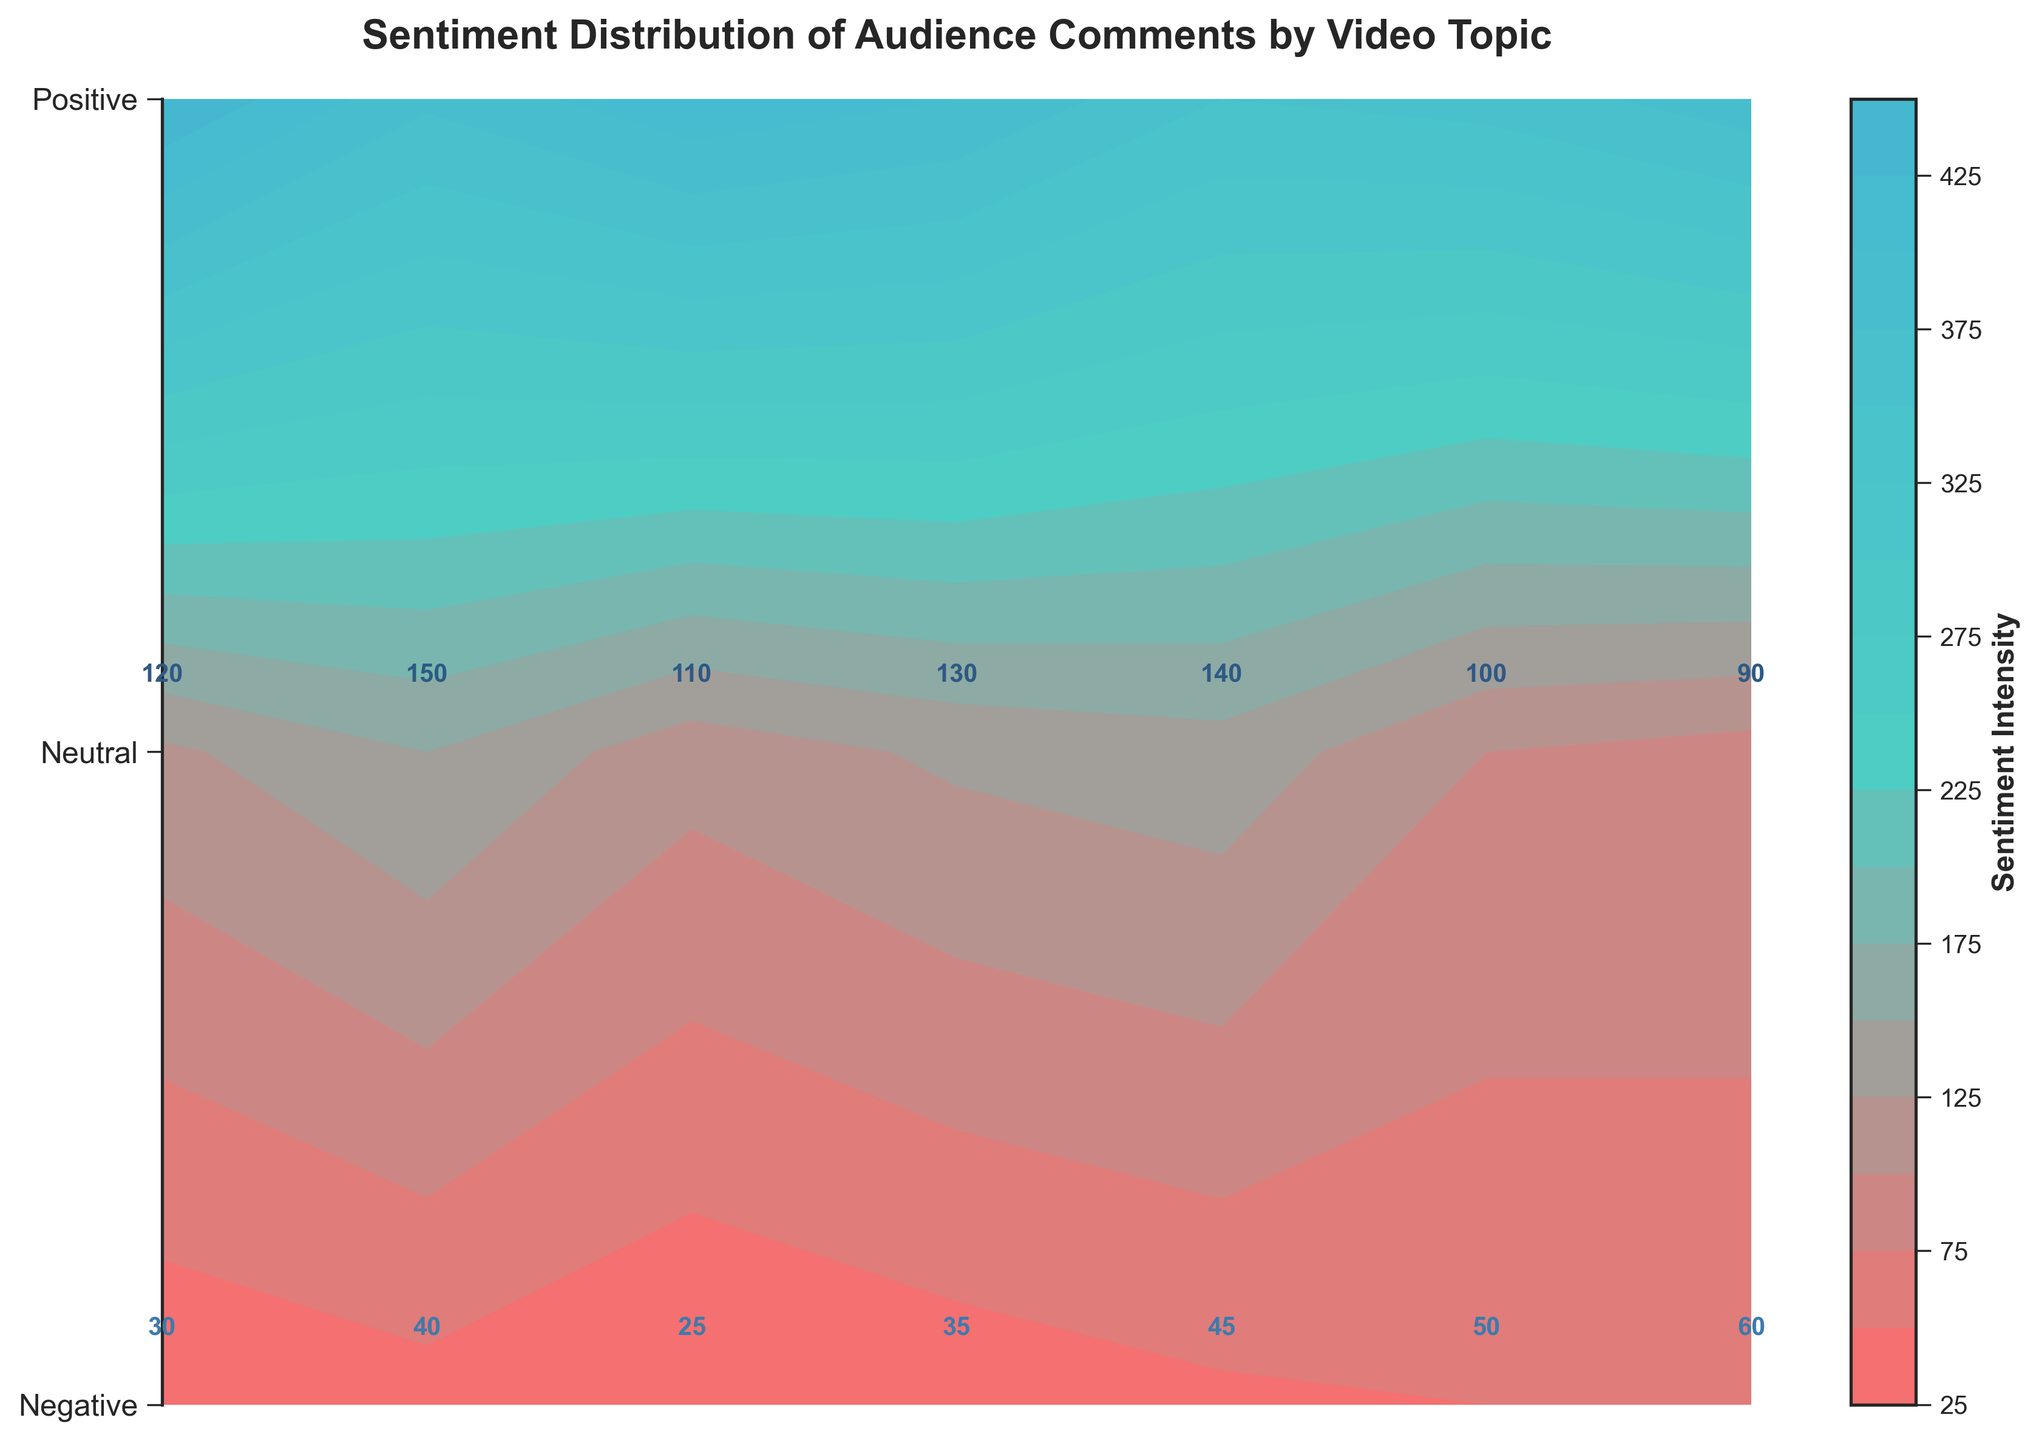What is the title of the figure? The title of the figure is displayed at the top, and it should be read directly from there.
Answer: Sentiment Distribution of Audience Comments by Video Topic How many video topics are depicted in the figure? Count the number of unique topics labeled along the x-axis to determine the total number. There are seven unique labels.
Answer: 7 Which video topic has the highest positive sentiment? Look at the labels on the x-axis and identify the highest number annotated for Positive Sentiment. Gadget Reviews has 450.
Answer: Gadget Reviews How does the negative sentiment for Tech News compare to Gaming Streams? Compare the negative sentiment values by looking at their annotations. Tech News has 50, while Gaming Streams has 60.
Answer: Tech News has fewer negative sentiments What is the total number of neutral sentiments for Cooking Tutorials and Fitness Tips? Add the neutral sentiment values for both topics: 110 (Cooking Tutorials) + 130 (Fitness Tips).
Answer: 240 Which video topic has the least total sentiment count? Sum the sentiments for each topic and compare: 
- Gadget Reviews: 450 + 120 + 30 = 600
- Travel Vlogs: 380 + 150 + 40 = 570
- Cooking Tutorials: 420 + 110 + 25 = 555
- Fitness Tips: 400 + 130 + 35 = 565
- Fashion Hauls: 350 + 140 + 45 = 535
- Tech News: 360 + 100 + 50 = 510
- Gaming Streams: 390 + 90 + 60 = 540.
Tech News has the lowest total.
Answer: Tech News Is there any video topic with more neutral sentiments than positive sentiments? Compare the neutral and positive sentiment values for each topic:
- Gadget Reviews (120 < 450)
- Travel Vlogs (150 < 380)
- Cooking Tutorials (110 < 420)
- Fitness Tips (130 < 400)
- Fashion Hauls (140 < 350)
- Tech News (100 < 360)
- Gaming Streams (90 < 390).
None of the topics meet this criterion.
Answer: No What is the average positive sentiment across all video topics? Sum the positive sentiments for all topics and divide by the number of topics: (450 + 380 + 420 + 400 + 350 + 360 + 390) / 7 = 2750 / 7 = 392.86
Answer: 392.86 Which video topic has the highest total sentiment count? Sum sentiments for each topic and identify the highest:
- Gadget Reviews: 450 + 120 + 30 = 600
- Travel Vlogs: 380 + 150 + 40 = 570
- Cooking Tutorials: 420 + 110 + 25 = 555
- Fitness Tips: 400 + 130 + 35 = 565
- Fashion Hauls: 350 + 140 + 45 = 535
- Tech News: 360 + 100 + 50 = 510
- Gaming Streams: 390 + 90 + 60 = 540.
Gadget Reviews has the highest total.
Answer: Gadget Reviews 